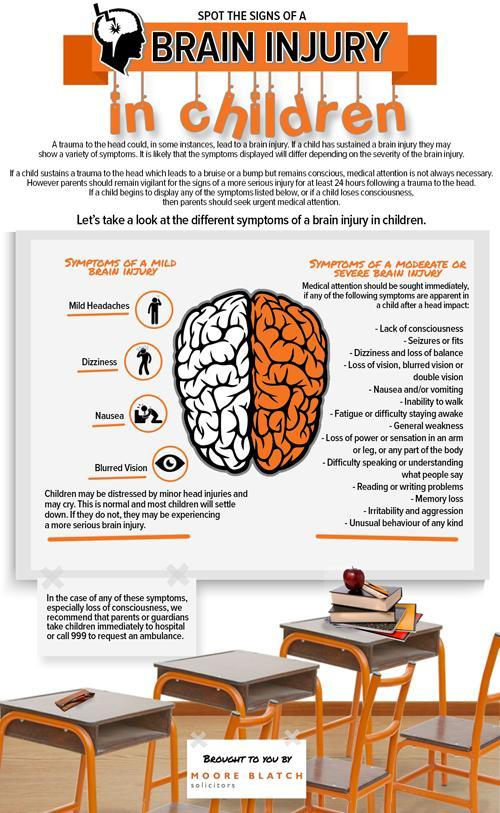How many symptoms are listed for a mild brain injury?
Answer the question with a short phrase. 4 